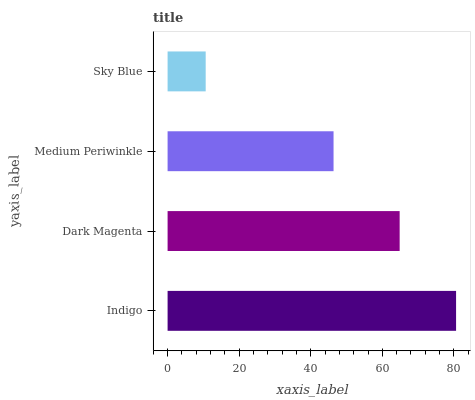Is Sky Blue the minimum?
Answer yes or no. Yes. Is Indigo the maximum?
Answer yes or no. Yes. Is Dark Magenta the minimum?
Answer yes or no. No. Is Dark Magenta the maximum?
Answer yes or no. No. Is Indigo greater than Dark Magenta?
Answer yes or no. Yes. Is Dark Magenta less than Indigo?
Answer yes or no. Yes. Is Dark Magenta greater than Indigo?
Answer yes or no. No. Is Indigo less than Dark Magenta?
Answer yes or no. No. Is Dark Magenta the high median?
Answer yes or no. Yes. Is Medium Periwinkle the low median?
Answer yes or no. Yes. Is Sky Blue the high median?
Answer yes or no. No. Is Indigo the low median?
Answer yes or no. No. 